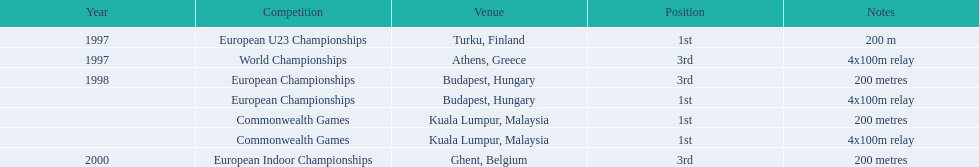In the 2000 european indoor championships, how long was the sprint race? 200 metres. 